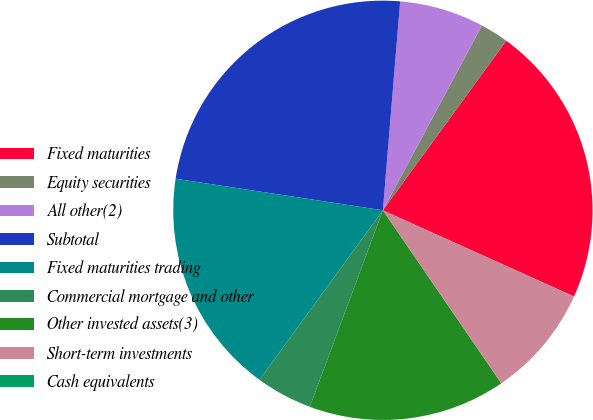<chart> <loc_0><loc_0><loc_500><loc_500><pie_chart><fcel>Fixed maturities<fcel>Equity securities<fcel>All other(2)<fcel>Subtotal<fcel>Fixed maturities trading<fcel>Commercial mortgage and other<fcel>Other invested assets(3)<fcel>Short-term investments<fcel>Cash equivalents<nl><fcel>21.73%<fcel>2.18%<fcel>6.52%<fcel>23.91%<fcel>17.39%<fcel>4.35%<fcel>15.22%<fcel>8.7%<fcel>0.01%<nl></chart> 